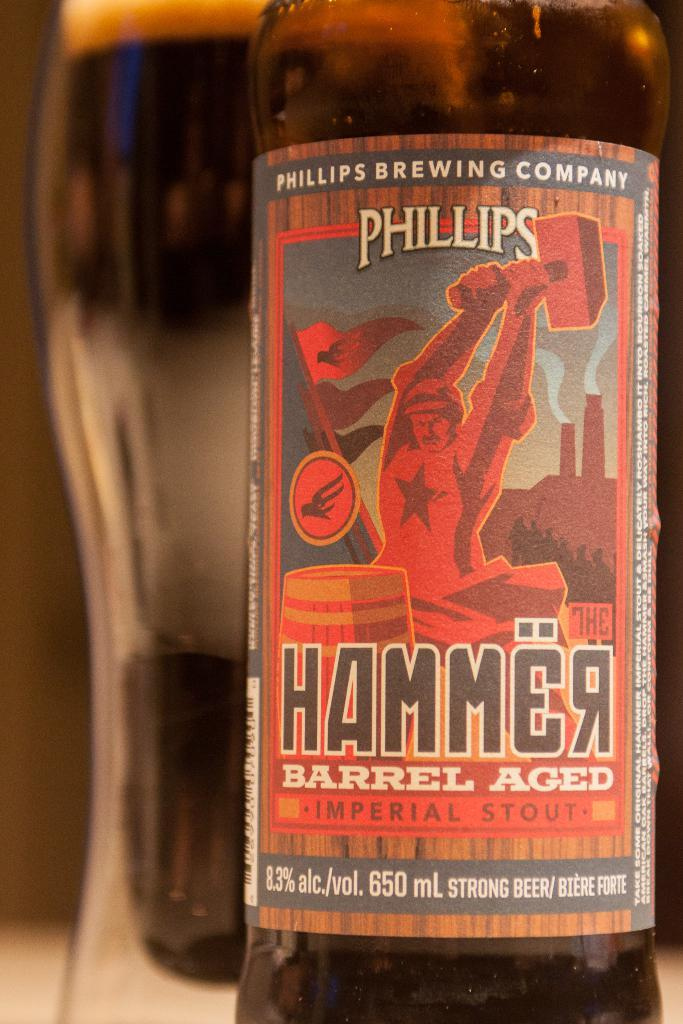<image>
Provide a brief description of the given image. The stout shown in the bottle is a barrel aged stout. 